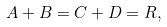<formula> <loc_0><loc_0><loc_500><loc_500>A + B = C + D = R ,</formula> 